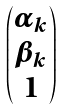Convert formula to latex. <formula><loc_0><loc_0><loc_500><loc_500>\begin{pmatrix} \alpha _ { k } \\ \beta _ { k } \\ 1 \end{pmatrix}</formula> 